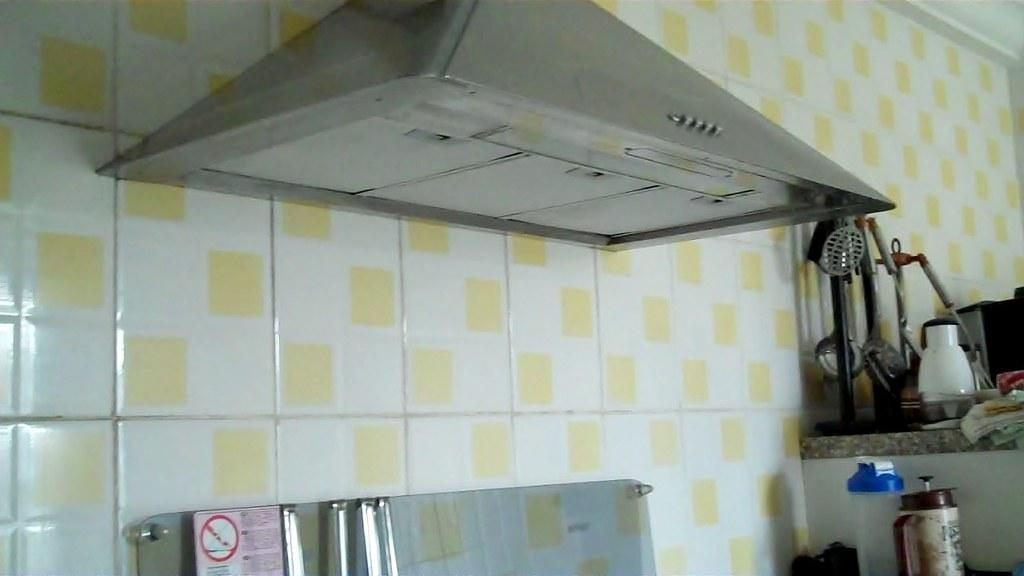What structure is attached to the wall in the image? There is a chimney attached to a wall in the image. What can be seen on the right side of the image? There are kitchen accessories on the right side of the image. What material covers the wall in the image? The wall is covered with tiles. What type of cork can be seen floating in the image? There is no cork present in the image. What drug is being prepared in the kitchen in the image? There is no drug preparation or reference to drugs in the image. 